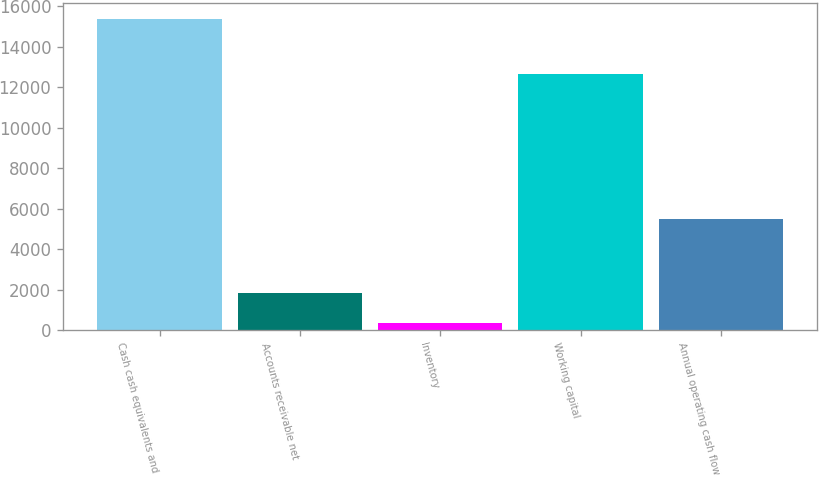<chart> <loc_0><loc_0><loc_500><loc_500><bar_chart><fcel>Cash cash equivalents and<fcel>Accounts receivable net<fcel>Inventory<fcel>Working capital<fcel>Annual operating cash flow<nl><fcel>15386<fcel>1850<fcel>346<fcel>12676<fcel>5470<nl></chart> 